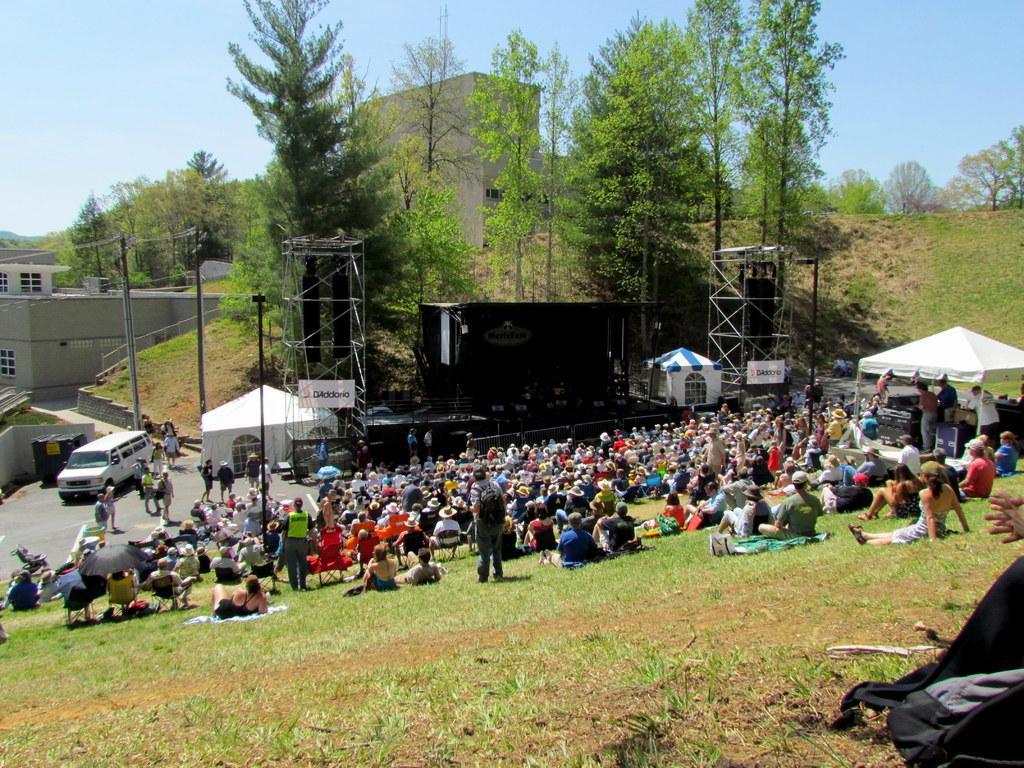In one or two sentences, can you explain what this image depicts? In this image I can see number of persons are sitting on chairs and few of them are sitting on ground. I can see few persons are standing on the ground, a white colored vehicle, few tents which are white and blue in color, the stage which is black in color and few metal poles. In the background I can see few buildings, few trees and the sky. 